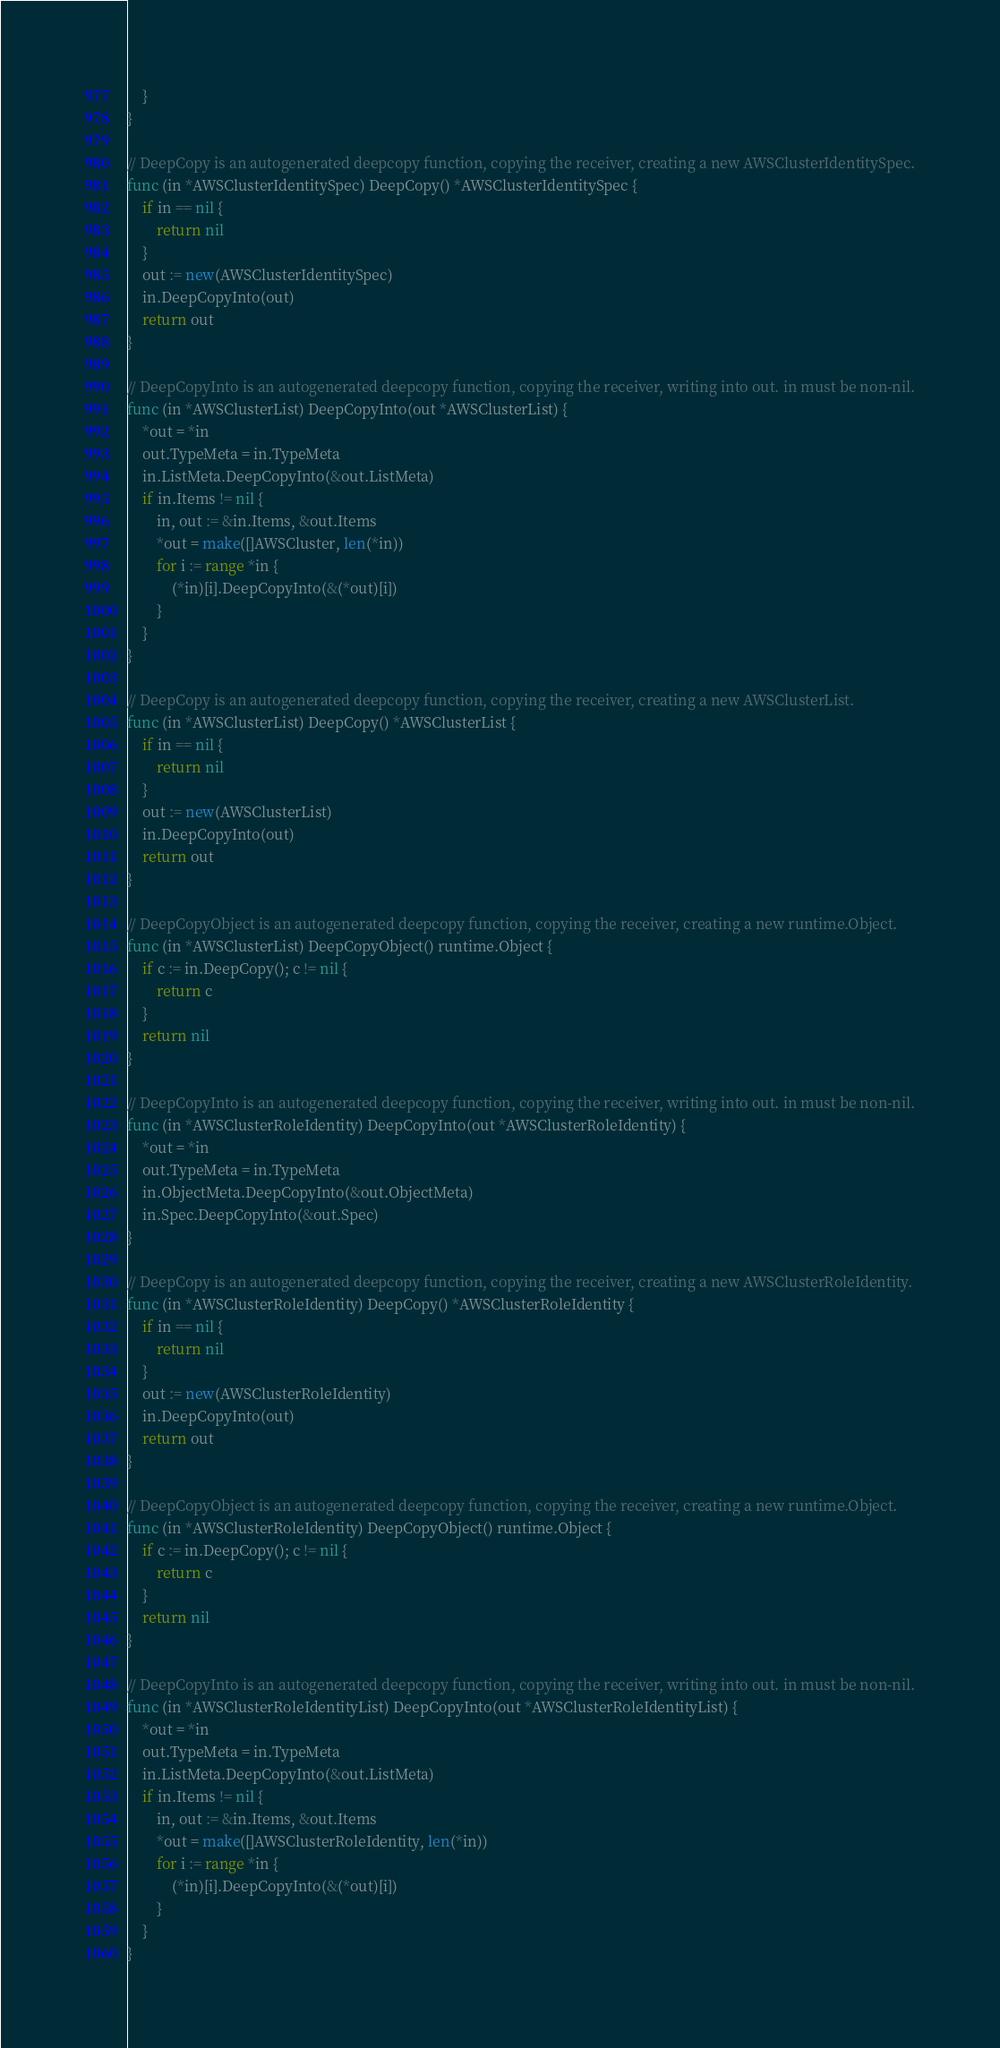<code> <loc_0><loc_0><loc_500><loc_500><_Go_>	}
}

// DeepCopy is an autogenerated deepcopy function, copying the receiver, creating a new AWSClusterIdentitySpec.
func (in *AWSClusterIdentitySpec) DeepCopy() *AWSClusterIdentitySpec {
	if in == nil {
		return nil
	}
	out := new(AWSClusterIdentitySpec)
	in.DeepCopyInto(out)
	return out
}

// DeepCopyInto is an autogenerated deepcopy function, copying the receiver, writing into out. in must be non-nil.
func (in *AWSClusterList) DeepCopyInto(out *AWSClusterList) {
	*out = *in
	out.TypeMeta = in.TypeMeta
	in.ListMeta.DeepCopyInto(&out.ListMeta)
	if in.Items != nil {
		in, out := &in.Items, &out.Items
		*out = make([]AWSCluster, len(*in))
		for i := range *in {
			(*in)[i].DeepCopyInto(&(*out)[i])
		}
	}
}

// DeepCopy is an autogenerated deepcopy function, copying the receiver, creating a new AWSClusterList.
func (in *AWSClusterList) DeepCopy() *AWSClusterList {
	if in == nil {
		return nil
	}
	out := new(AWSClusterList)
	in.DeepCopyInto(out)
	return out
}

// DeepCopyObject is an autogenerated deepcopy function, copying the receiver, creating a new runtime.Object.
func (in *AWSClusterList) DeepCopyObject() runtime.Object {
	if c := in.DeepCopy(); c != nil {
		return c
	}
	return nil
}

// DeepCopyInto is an autogenerated deepcopy function, copying the receiver, writing into out. in must be non-nil.
func (in *AWSClusterRoleIdentity) DeepCopyInto(out *AWSClusterRoleIdentity) {
	*out = *in
	out.TypeMeta = in.TypeMeta
	in.ObjectMeta.DeepCopyInto(&out.ObjectMeta)
	in.Spec.DeepCopyInto(&out.Spec)
}

// DeepCopy is an autogenerated deepcopy function, copying the receiver, creating a new AWSClusterRoleIdentity.
func (in *AWSClusterRoleIdentity) DeepCopy() *AWSClusterRoleIdentity {
	if in == nil {
		return nil
	}
	out := new(AWSClusterRoleIdentity)
	in.DeepCopyInto(out)
	return out
}

// DeepCopyObject is an autogenerated deepcopy function, copying the receiver, creating a new runtime.Object.
func (in *AWSClusterRoleIdentity) DeepCopyObject() runtime.Object {
	if c := in.DeepCopy(); c != nil {
		return c
	}
	return nil
}

// DeepCopyInto is an autogenerated deepcopy function, copying the receiver, writing into out. in must be non-nil.
func (in *AWSClusterRoleIdentityList) DeepCopyInto(out *AWSClusterRoleIdentityList) {
	*out = *in
	out.TypeMeta = in.TypeMeta
	in.ListMeta.DeepCopyInto(&out.ListMeta)
	if in.Items != nil {
		in, out := &in.Items, &out.Items
		*out = make([]AWSClusterRoleIdentity, len(*in))
		for i := range *in {
			(*in)[i].DeepCopyInto(&(*out)[i])
		}
	}
}
</code> 